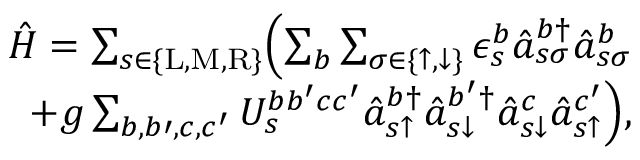<formula> <loc_0><loc_0><loc_500><loc_500>\begin{array} { r } { \hat { H } = \sum _ { s \in \{ L , M , R \} } \left ( \sum _ { b } \sum _ { \sigma \in \{ \uparrow , \downarrow \} } \epsilon _ { s } ^ { b } \hat { a } _ { s \sigma } ^ { b \dagger } \hat { a } _ { s \sigma } ^ { b } } \\ { + g \sum _ { b , b \prime , c , c ^ { \prime } } U _ { s } ^ { b b ^ { \prime } c c ^ { \prime } } \hat { a } _ { s \uparrow } ^ { b \dagger } \hat { a } _ { s \downarrow } ^ { b ^ { \prime } \dagger } \hat { a } _ { s \downarrow } ^ { c } \hat { a } _ { s \uparrow } ^ { c ^ { \prime } } \right ) , } \end{array}</formula> 